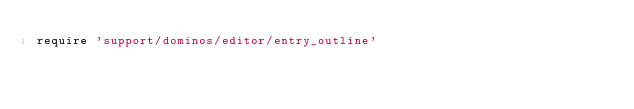<code> <loc_0><loc_0><loc_500><loc_500><_Ruby_>require 'support/dominos/editor/entry_outline'
</code> 